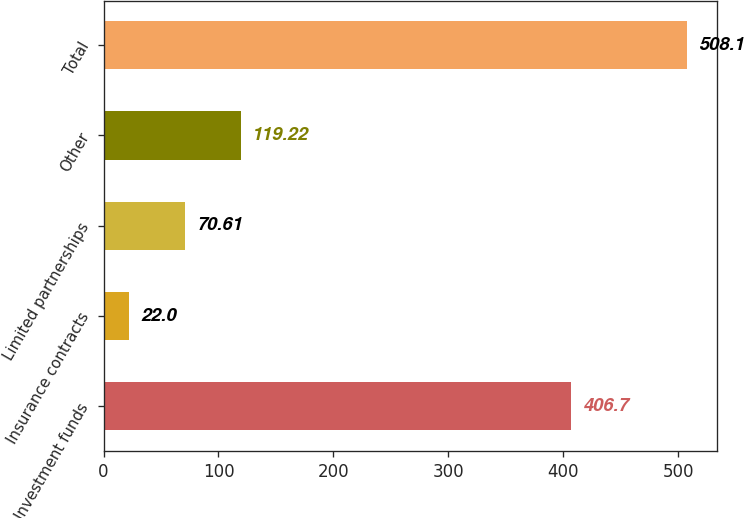Convert chart to OTSL. <chart><loc_0><loc_0><loc_500><loc_500><bar_chart><fcel>Investment funds<fcel>Insurance contracts<fcel>Limited partnerships<fcel>Other<fcel>Total<nl><fcel>406.7<fcel>22<fcel>70.61<fcel>119.22<fcel>508.1<nl></chart> 